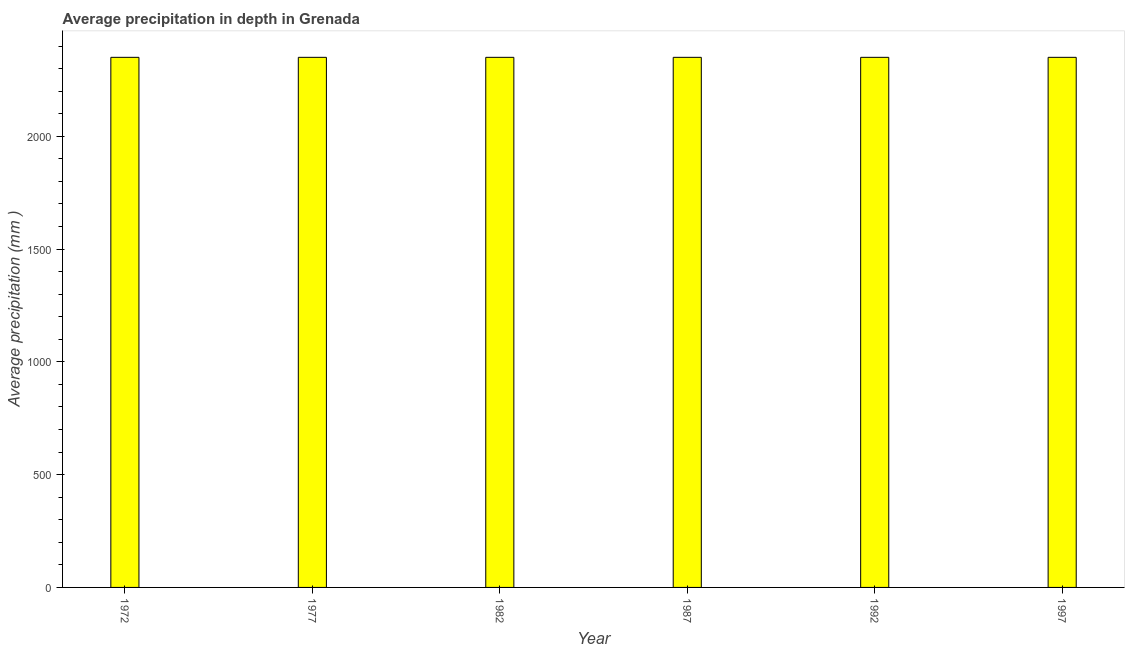Does the graph contain any zero values?
Your response must be concise. No. Does the graph contain grids?
Ensure brevity in your answer.  No. What is the title of the graph?
Your response must be concise. Average precipitation in depth in Grenada. What is the label or title of the X-axis?
Offer a terse response. Year. What is the label or title of the Y-axis?
Offer a very short reply. Average precipitation (mm ). What is the average precipitation in depth in 1992?
Keep it short and to the point. 2350. Across all years, what is the maximum average precipitation in depth?
Ensure brevity in your answer.  2350. Across all years, what is the minimum average precipitation in depth?
Keep it short and to the point. 2350. In which year was the average precipitation in depth minimum?
Ensure brevity in your answer.  1972. What is the sum of the average precipitation in depth?
Your answer should be compact. 1.41e+04. What is the average average precipitation in depth per year?
Provide a short and direct response. 2350. What is the median average precipitation in depth?
Your answer should be very brief. 2350. In how many years, is the average precipitation in depth greater than 1100 mm?
Offer a very short reply. 6. Do a majority of the years between 1987 and 1997 (inclusive) have average precipitation in depth greater than 800 mm?
Provide a succinct answer. Yes. What is the ratio of the average precipitation in depth in 1982 to that in 1992?
Your answer should be very brief. 1. Is the average precipitation in depth in 1987 less than that in 1997?
Your answer should be compact. No. Is the difference between the average precipitation in depth in 1977 and 1987 greater than the difference between any two years?
Offer a terse response. Yes. What is the difference between the highest and the second highest average precipitation in depth?
Ensure brevity in your answer.  0. Is the sum of the average precipitation in depth in 1972 and 1977 greater than the maximum average precipitation in depth across all years?
Provide a succinct answer. Yes. What is the difference between the highest and the lowest average precipitation in depth?
Provide a short and direct response. 0. Are all the bars in the graph horizontal?
Give a very brief answer. No. How many years are there in the graph?
Keep it short and to the point. 6. What is the Average precipitation (mm ) in 1972?
Your answer should be compact. 2350. What is the Average precipitation (mm ) in 1977?
Give a very brief answer. 2350. What is the Average precipitation (mm ) in 1982?
Give a very brief answer. 2350. What is the Average precipitation (mm ) in 1987?
Offer a very short reply. 2350. What is the Average precipitation (mm ) in 1992?
Give a very brief answer. 2350. What is the Average precipitation (mm ) of 1997?
Make the answer very short. 2350. What is the difference between the Average precipitation (mm ) in 1972 and 1987?
Your answer should be compact. 0. What is the difference between the Average precipitation (mm ) in 1972 and 1992?
Your response must be concise. 0. What is the difference between the Average precipitation (mm ) in 1977 and 1982?
Your answer should be compact. 0. What is the difference between the Average precipitation (mm ) in 1982 and 1992?
Offer a very short reply. 0. What is the difference between the Average precipitation (mm ) in 1982 and 1997?
Your response must be concise. 0. What is the difference between the Average precipitation (mm ) in 1987 and 1992?
Your answer should be very brief. 0. What is the difference between the Average precipitation (mm ) in 1987 and 1997?
Your response must be concise. 0. What is the ratio of the Average precipitation (mm ) in 1972 to that in 1982?
Offer a very short reply. 1. What is the ratio of the Average precipitation (mm ) in 1972 to that in 1987?
Provide a short and direct response. 1. What is the ratio of the Average precipitation (mm ) in 1972 to that in 1992?
Provide a short and direct response. 1. What is the ratio of the Average precipitation (mm ) in 1972 to that in 1997?
Your response must be concise. 1. What is the ratio of the Average precipitation (mm ) in 1977 to that in 1982?
Provide a short and direct response. 1. What is the ratio of the Average precipitation (mm ) in 1977 to that in 1987?
Offer a very short reply. 1. What is the ratio of the Average precipitation (mm ) in 1977 to that in 1997?
Your answer should be very brief. 1. What is the ratio of the Average precipitation (mm ) in 1982 to that in 1992?
Make the answer very short. 1. What is the ratio of the Average precipitation (mm ) in 1987 to that in 1992?
Provide a short and direct response. 1. What is the ratio of the Average precipitation (mm ) in 1987 to that in 1997?
Ensure brevity in your answer.  1. What is the ratio of the Average precipitation (mm ) in 1992 to that in 1997?
Provide a short and direct response. 1. 